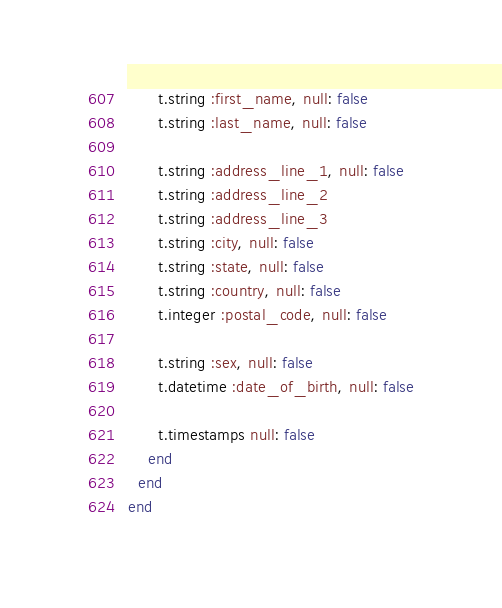<code> <loc_0><loc_0><loc_500><loc_500><_Ruby_>      t.string :first_name, null: false
      t.string :last_name, null: false

      t.string :address_line_1, null: false
      t.string :address_line_2
      t.string :address_line_3
      t.string :city, null: false
      t.string :state, null: false
      t.string :country, null: false
      t.integer :postal_code, null: false

      t.string :sex, null: false
      t.datetime :date_of_birth, null: false

      t.timestamps null: false
    end
  end
end
</code> 